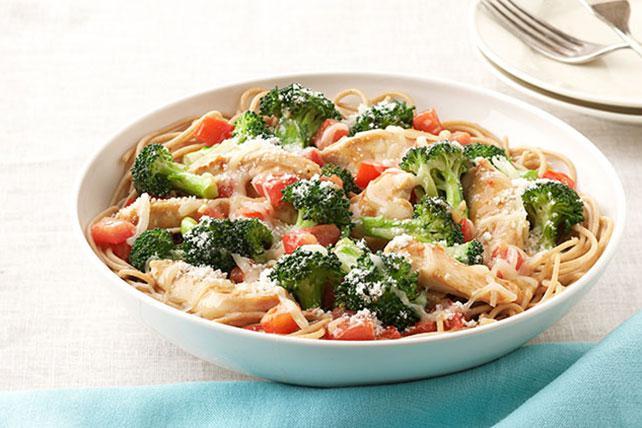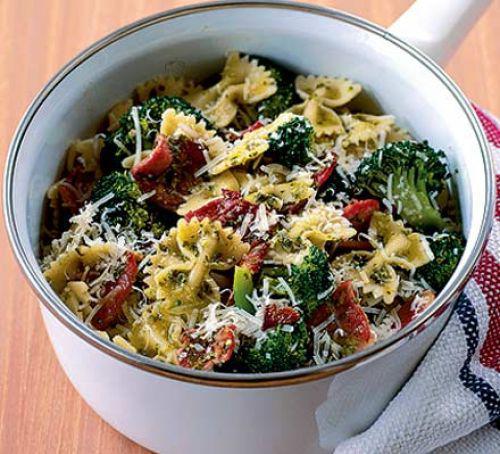The first image is the image on the left, the second image is the image on the right. Evaluate the accuracy of this statement regarding the images: "An image shows a round bowl of broccoli and pasta with a silver serving spoon inserted in it.". Is it true? Answer yes or no. No. The first image is the image on the left, the second image is the image on the right. Assess this claim about the two images: "The bowl in the image on the left is white and round.". Correct or not? Answer yes or no. Yes. 